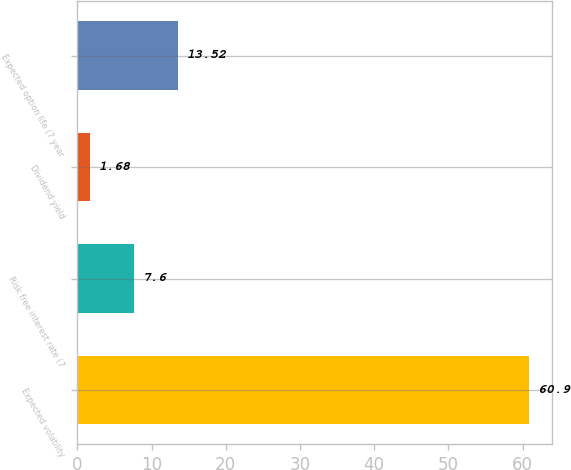Convert chart. <chart><loc_0><loc_0><loc_500><loc_500><bar_chart><fcel>Expected volatility<fcel>Risk free interest rate (7<fcel>Dividend yield<fcel>Expected option life (7 year<nl><fcel>60.9<fcel>7.6<fcel>1.68<fcel>13.52<nl></chart> 